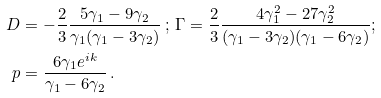Convert formula to latex. <formula><loc_0><loc_0><loc_500><loc_500>D & = - \frac { 2 } { 3 } \frac { 5 \gamma _ { 1 } - 9 \gamma _ { 2 } } { \gamma _ { 1 } ( \gamma _ { 1 } - 3 \gamma _ { 2 } ) } \ ; \ \Gamma = \frac { 2 } { 3 } \frac { 4 \gamma _ { 1 } ^ { 2 } - 2 7 \gamma _ { 2 } ^ { 2 } } { ( \gamma _ { 1 } - 3 \gamma _ { 2 } ) ( \gamma _ { 1 } - 6 \gamma _ { 2 } ) } ; \\ p & = \frac { 6 \gamma _ { 1 } e ^ { i k } } { \gamma _ { 1 } - 6 \gamma _ { 2 } } \, .</formula> 